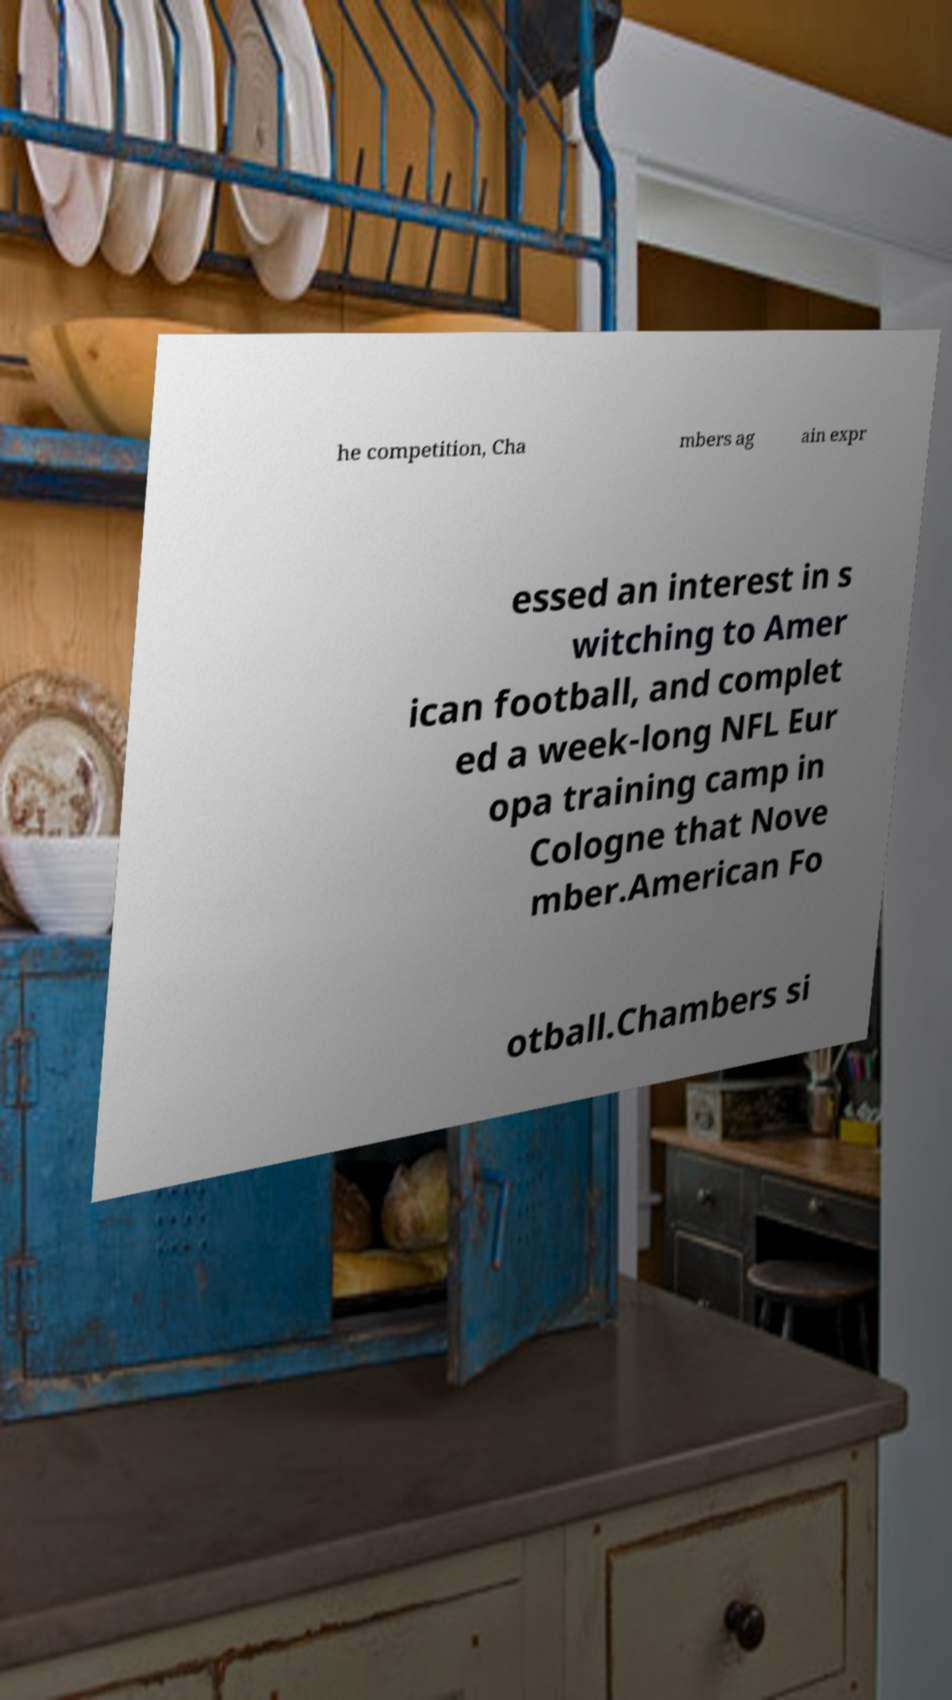Please read and relay the text visible in this image. What does it say? he competition, Cha mbers ag ain expr essed an interest in s witching to Amer ican football, and complet ed a week-long NFL Eur opa training camp in Cologne that Nove mber.American Fo otball.Chambers si 